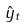<formula> <loc_0><loc_0><loc_500><loc_500>\hat { y } _ { t }</formula> 